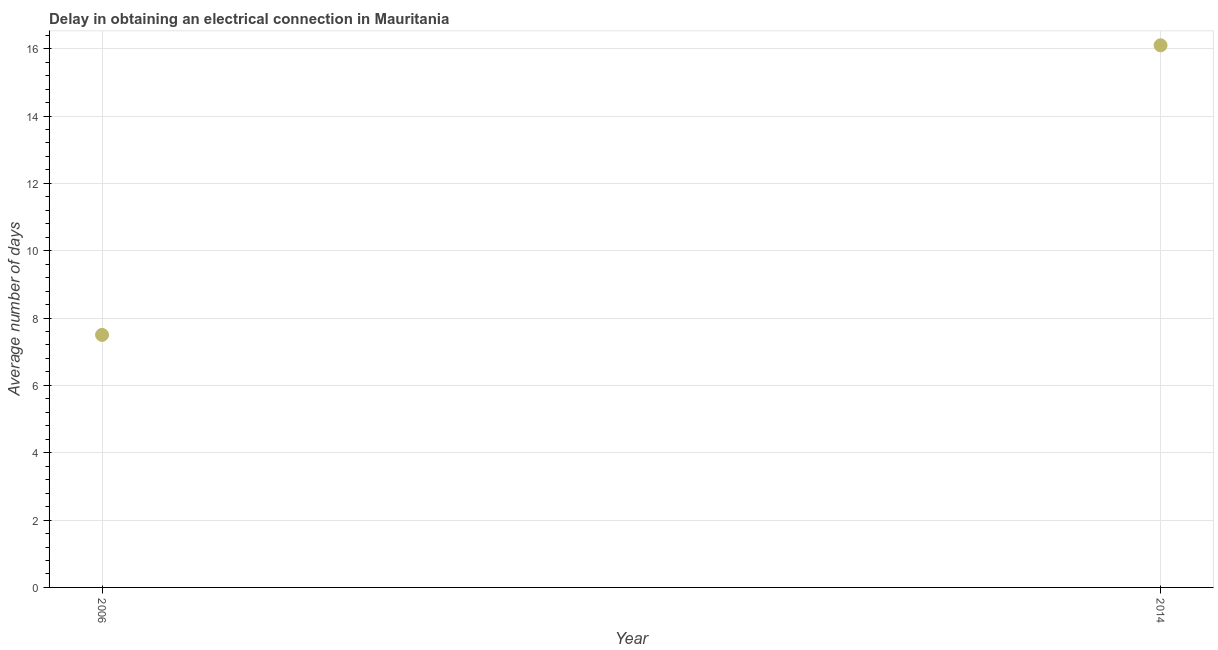In which year was the dalay in electrical connection maximum?
Make the answer very short. 2014. What is the sum of the dalay in electrical connection?
Your response must be concise. 23.6. What is the difference between the dalay in electrical connection in 2006 and 2014?
Keep it short and to the point. -8.6. Do a majority of the years between 2006 and 2014 (inclusive) have dalay in electrical connection greater than 10.4 days?
Make the answer very short. No. What is the ratio of the dalay in electrical connection in 2006 to that in 2014?
Offer a very short reply. 0.47. In how many years, is the dalay in electrical connection greater than the average dalay in electrical connection taken over all years?
Provide a succinct answer. 1. How many dotlines are there?
Give a very brief answer. 1. How many years are there in the graph?
Keep it short and to the point. 2. Are the values on the major ticks of Y-axis written in scientific E-notation?
Your answer should be very brief. No. Does the graph contain grids?
Make the answer very short. Yes. What is the title of the graph?
Your answer should be compact. Delay in obtaining an electrical connection in Mauritania. What is the label or title of the Y-axis?
Offer a terse response. Average number of days. What is the difference between the Average number of days in 2006 and 2014?
Offer a very short reply. -8.6. What is the ratio of the Average number of days in 2006 to that in 2014?
Provide a short and direct response. 0.47. 